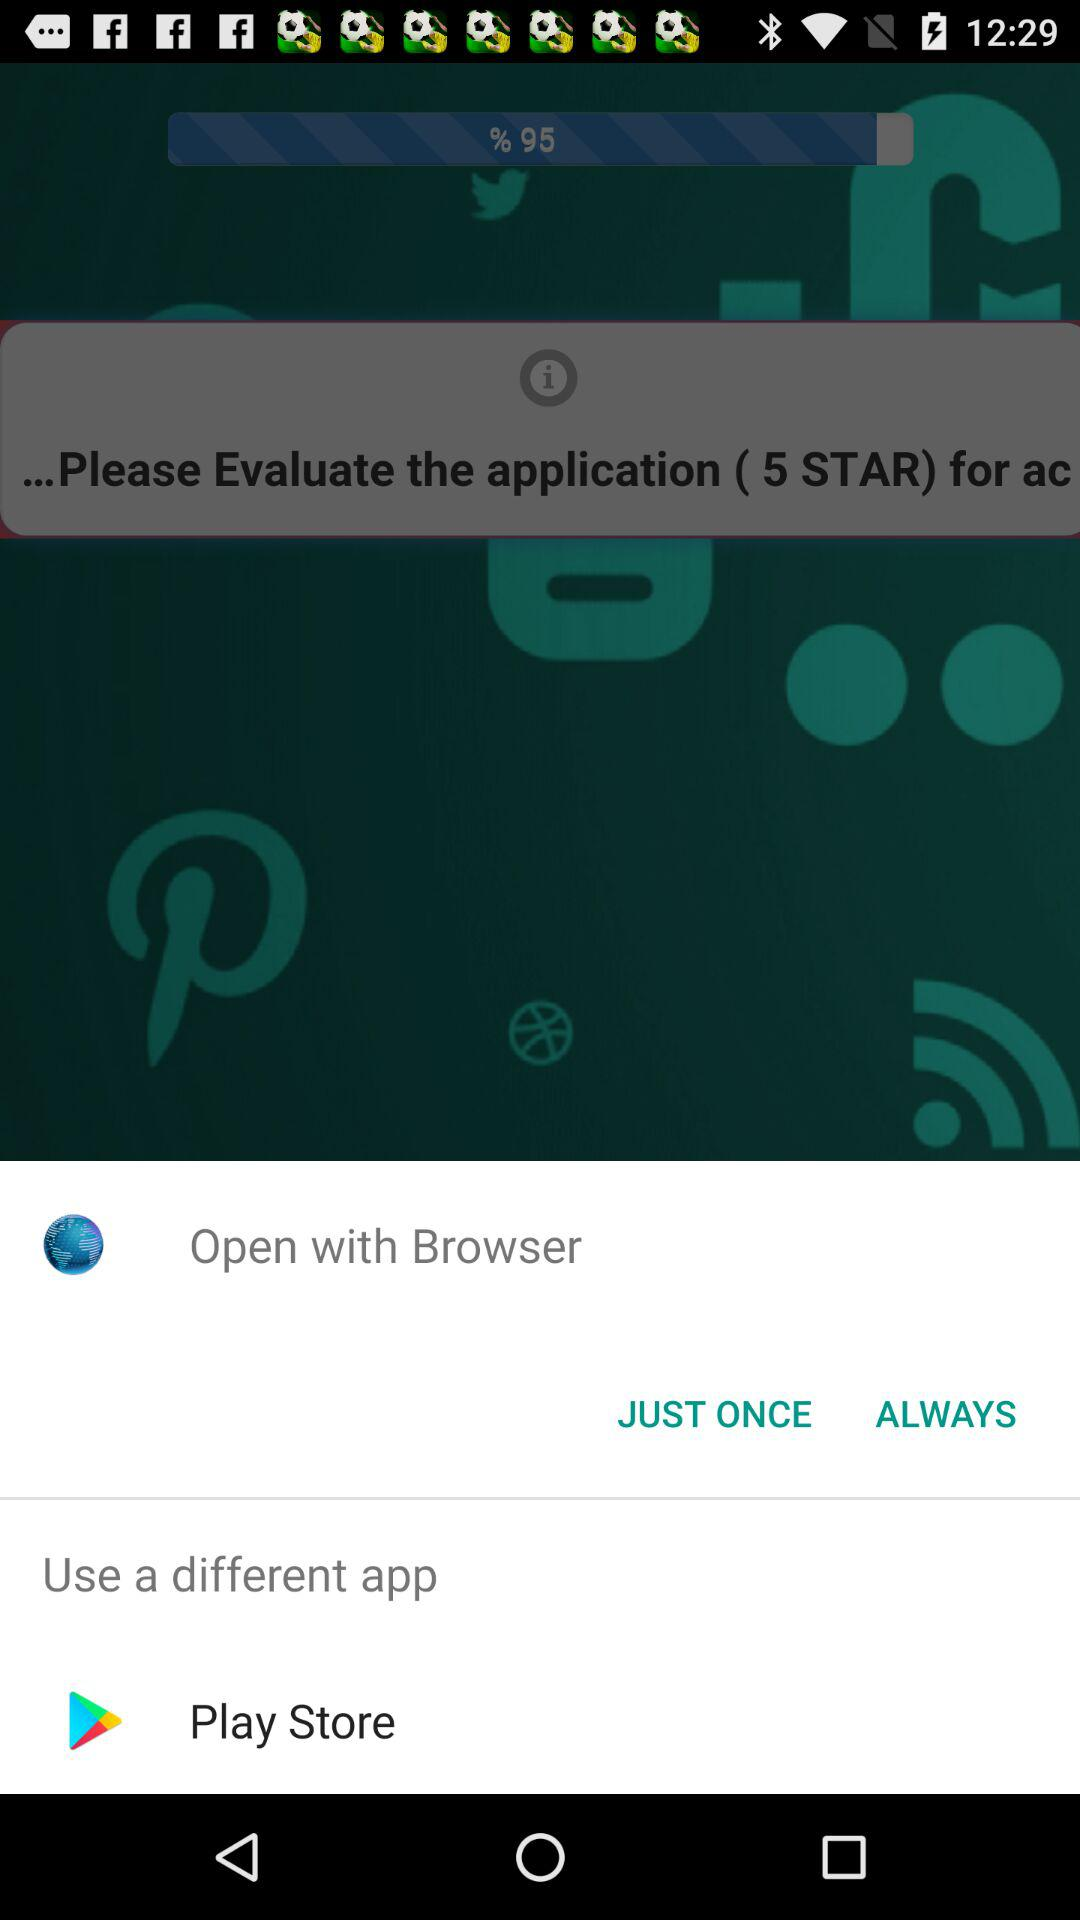What other applications can be used? The other application that can be used is "Play Store". 